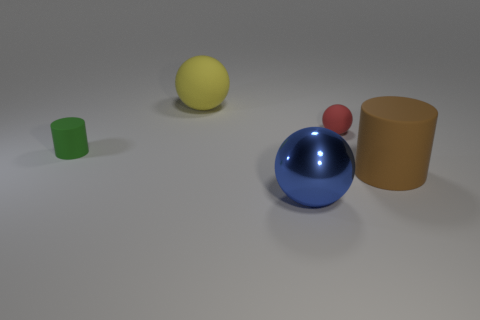Add 4 large metal things. How many objects exist? 9 Subtract all cylinders. How many objects are left? 3 Add 1 brown cylinders. How many brown cylinders are left? 2 Add 4 red matte spheres. How many red matte spheres exist? 5 Subtract 0 gray cubes. How many objects are left? 5 Subtract all large blue matte things. Subtract all large matte objects. How many objects are left? 3 